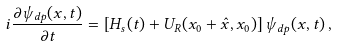Convert formula to latex. <formula><loc_0><loc_0><loc_500><loc_500>i \frac { \partial \psi _ { d p } ( x , t ) } { \partial t } = \left [ H _ { s } ( t ) + U _ { R } ( x _ { 0 } + \hat { x } , x _ { 0 } ) \right ] \psi _ { d p } ( x , t ) \, ,</formula> 